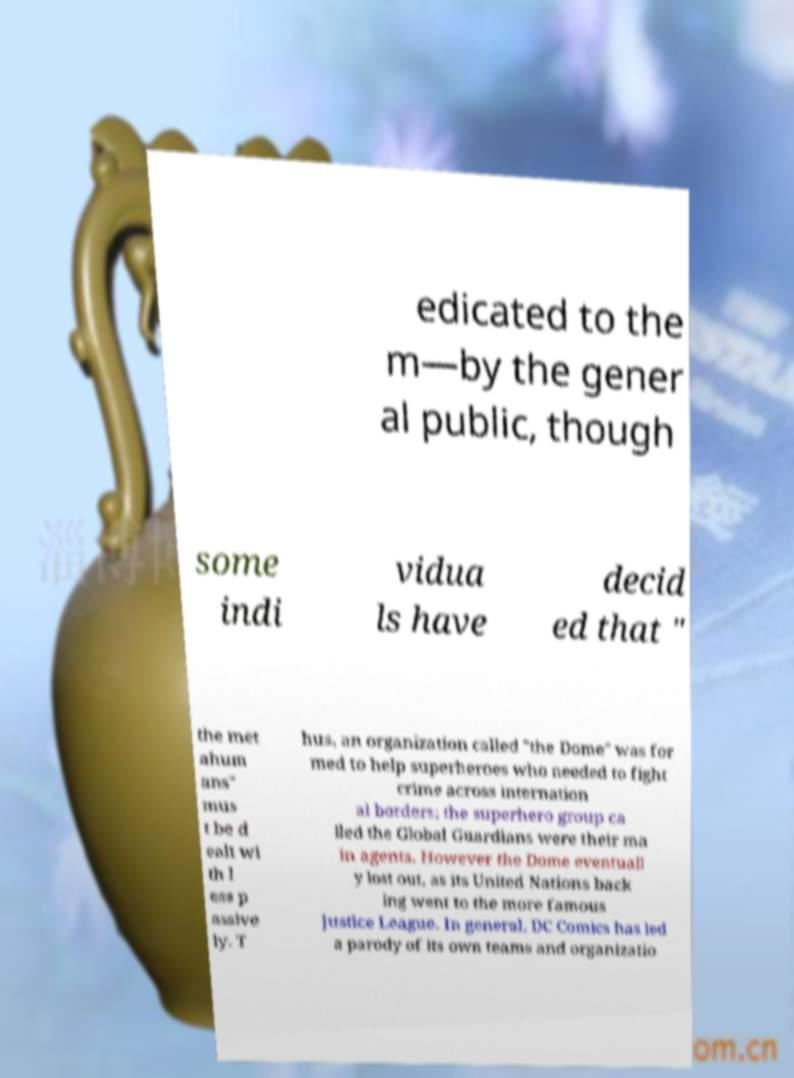For documentation purposes, I need the text within this image transcribed. Could you provide that? edicated to the m—by the gener al public, though some indi vidua ls have decid ed that " the met ahum ans" mus t be d ealt wi th l ess p assive ly. T hus, an organization called "the Dome" was for med to help superheroes who needed to fight crime across internation al borders; the superhero group ca lled the Global Guardians were their ma in agents. However the Dome eventuall y lost out, as its United Nations back ing went to the more famous Justice League. In general, DC Comics has led a parody of its own teams and organizatio 